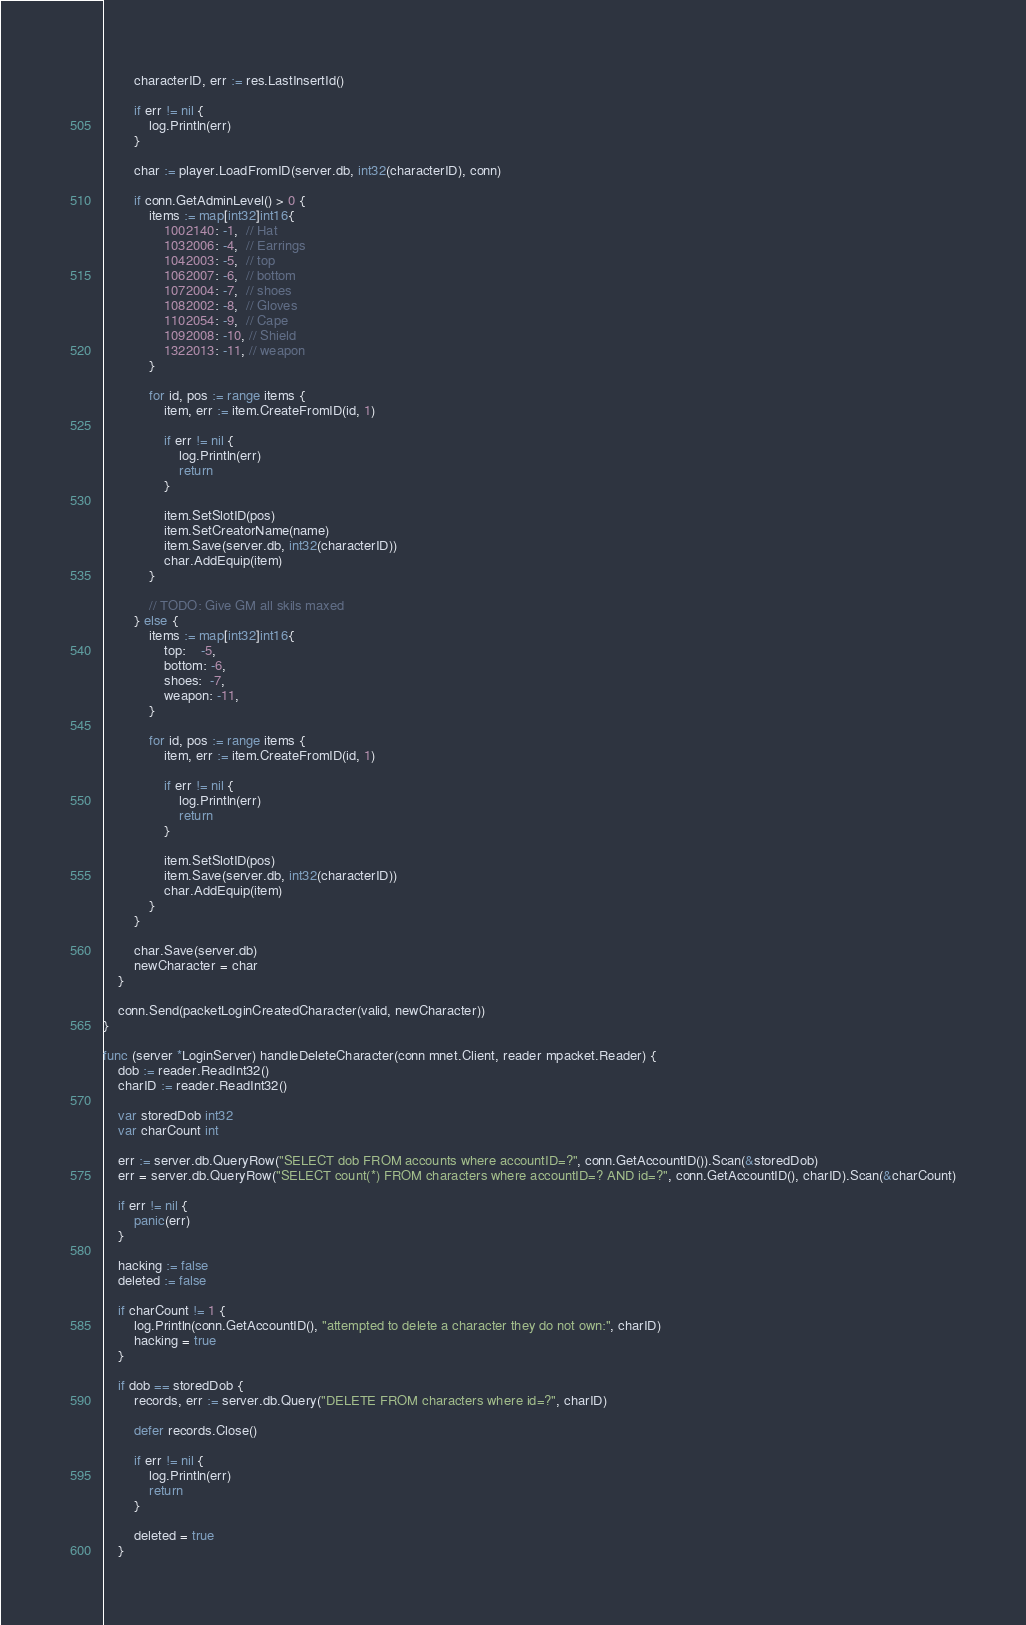Convert code to text. <code><loc_0><loc_0><loc_500><loc_500><_Go_>		characterID, err := res.LastInsertId()

		if err != nil {
			log.Println(err)
		}

		char := player.LoadFromID(server.db, int32(characterID), conn)

		if conn.GetAdminLevel() > 0 {
			items := map[int32]int16{
				1002140: -1,  // Hat
				1032006: -4,  // Earrings
				1042003: -5,  // top
				1062007: -6,  // bottom
				1072004: -7,  // shoes
				1082002: -8,  // Gloves
				1102054: -9,  // Cape
				1092008: -10, // Shield
				1322013: -11, // weapon
			}

			for id, pos := range items {
				item, err := item.CreateFromID(id, 1)

				if err != nil {
					log.Println(err)
					return
				}

				item.SetSlotID(pos)
				item.SetCreatorName(name)
				item.Save(server.db, int32(characterID))
				char.AddEquip(item)
			}

			// TODO: Give GM all skils maxed
		} else {
			items := map[int32]int16{
				top:    -5,
				bottom: -6,
				shoes:  -7,
				weapon: -11,
			}

			for id, pos := range items {
				item, err := item.CreateFromID(id, 1)

				if err != nil {
					log.Println(err)
					return
				}

				item.SetSlotID(pos)
				item.Save(server.db, int32(characterID))
				char.AddEquip(item)
			}
		}

		char.Save(server.db)
		newCharacter = char
	}

	conn.Send(packetLoginCreatedCharacter(valid, newCharacter))
}

func (server *LoginServer) handleDeleteCharacter(conn mnet.Client, reader mpacket.Reader) {
	dob := reader.ReadInt32()
	charID := reader.ReadInt32()

	var storedDob int32
	var charCount int

	err := server.db.QueryRow("SELECT dob FROM accounts where accountID=?", conn.GetAccountID()).Scan(&storedDob)
	err = server.db.QueryRow("SELECT count(*) FROM characters where accountID=? AND id=?", conn.GetAccountID(), charID).Scan(&charCount)

	if err != nil {
		panic(err)
	}

	hacking := false
	deleted := false

	if charCount != 1 {
		log.Println(conn.GetAccountID(), "attempted to delete a character they do not own:", charID)
		hacking = true
	}

	if dob == storedDob {
		records, err := server.db.Query("DELETE FROM characters where id=?", charID)

		defer records.Close()

		if err != nil {
			log.Println(err)
			return
		}

		deleted = true
	}
</code> 